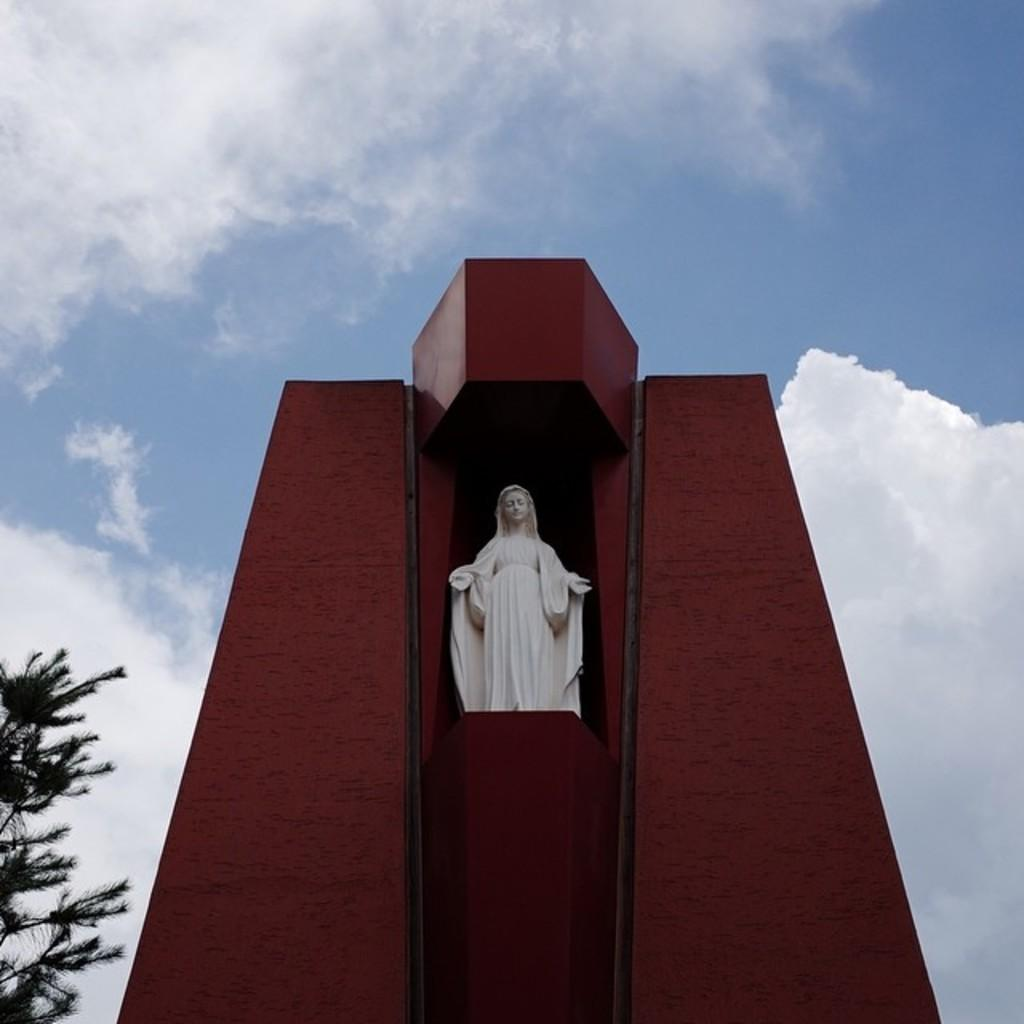What is the main subject in the image? There is a statue in the image. Can you describe the statue's appearance? The statue is white in color. What is the statue resting on? The statue is on a red object. What other natural element can be seen in the image? There is a tree in the image. What is visible in the background of the image? The sky is visible in the background of the image. How much payment is required to enter the area with the statue and tree? There is no mention of payment or an entrance fee in the image, so it cannot be determined. What type of milk is being served in the image? There is no milk present in the image; it features a statue, a red object, a tree, and the sky. 